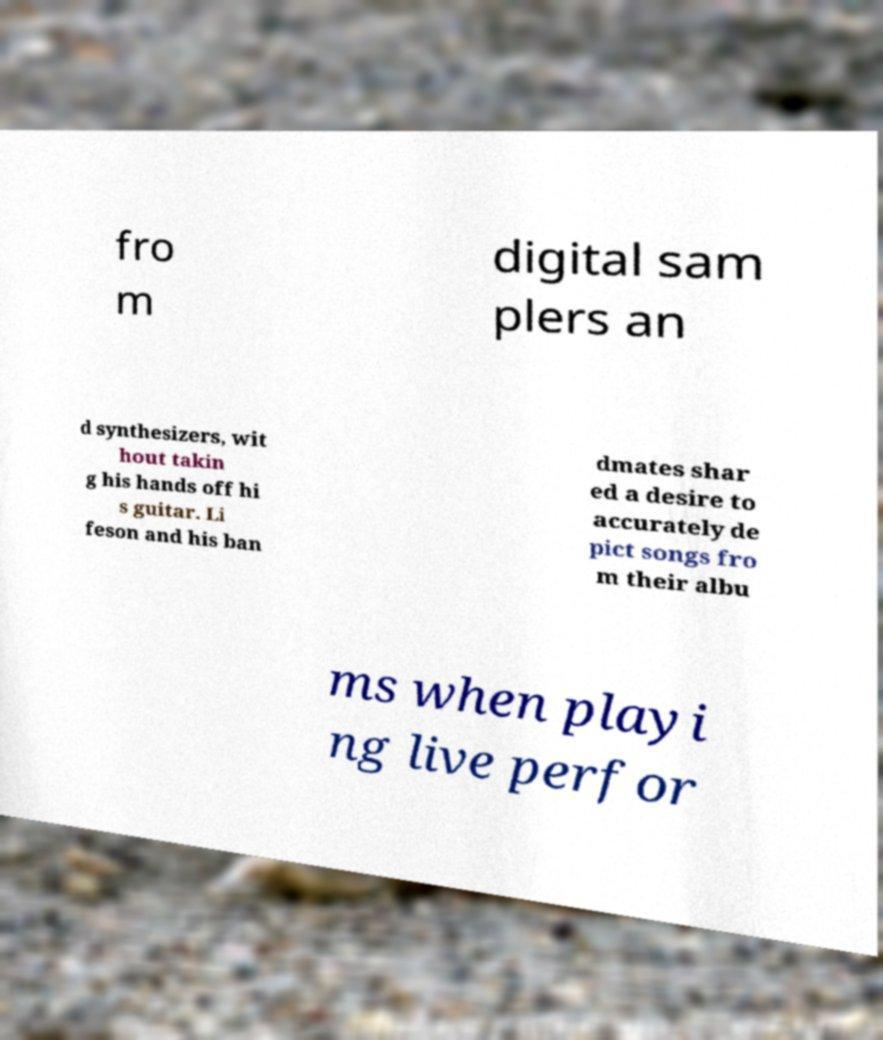Can you accurately transcribe the text from the provided image for me? fro m digital sam plers an d synthesizers, wit hout takin g his hands off hi s guitar. Li feson and his ban dmates shar ed a desire to accurately de pict songs fro m their albu ms when playi ng live perfor 